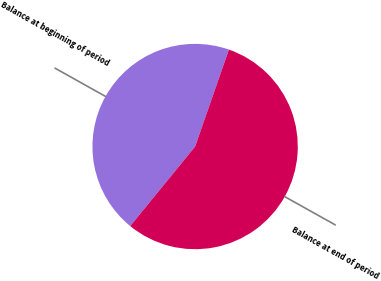<chart> <loc_0><loc_0><loc_500><loc_500><pie_chart><fcel>Balance at beginning of period<fcel>Balance at end of period<nl><fcel>44.44%<fcel>55.56%<nl></chart> 